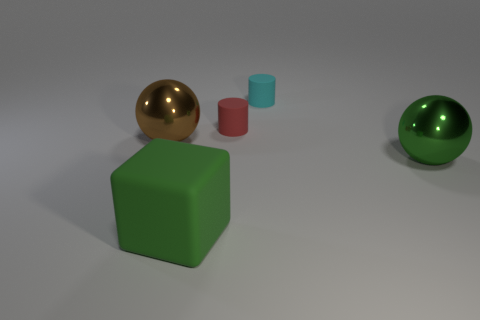Are there any balls that have the same material as the small cyan thing?
Provide a succinct answer. No. What number of objects are tiny green metallic cylinders or small cyan cylinders?
Your answer should be compact. 1. Does the cube have the same material as the sphere behind the large green sphere?
Offer a very short reply. No. There is a shiny object that is left of the cube; what size is it?
Your response must be concise. Large. Is the number of cyan rubber cylinders less than the number of small metal blocks?
Provide a short and direct response. No. Is there a big sphere of the same color as the rubber block?
Offer a terse response. Yes. The big object that is both left of the small cyan cylinder and in front of the large brown metal sphere has what shape?
Ensure brevity in your answer.  Cube. What shape is the tiny object to the right of the matte cylinder left of the tiny cyan rubber cylinder?
Ensure brevity in your answer.  Cylinder. Is the tiny red thing the same shape as the large brown metal thing?
Offer a very short reply. No. What is the material of the big object that is the same color as the large cube?
Offer a terse response. Metal. 